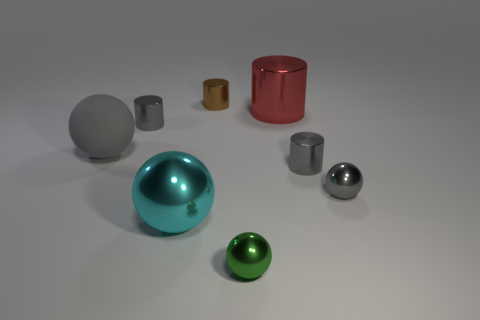What number of tiny objects are behind the big metal sphere and in front of the red metallic cylinder?
Give a very brief answer. 3. Is the number of tiny brown shiny cylinders that are on the right side of the small green shiny object the same as the number of tiny gray shiny cylinders to the right of the red thing?
Ensure brevity in your answer.  No. There is a gray metal cylinder that is to the left of the brown cylinder; is it the same size as the ball in front of the big cyan ball?
Your response must be concise. Yes. There is a small object that is both in front of the big matte ball and on the left side of the big red metallic cylinder; what material is it?
Make the answer very short. Metal. Are there fewer large shiny balls than large blue objects?
Make the answer very short. No. There is a object that is in front of the cyan object on the right side of the large rubber sphere; what is its size?
Your response must be concise. Small. There is a small thing that is in front of the small gray thing in front of the tiny gray metallic cylinder to the right of the brown cylinder; what shape is it?
Give a very brief answer. Sphere. What color is the large cylinder that is the same material as the cyan object?
Your answer should be very brief. Red. What is the color of the ball that is right of the tiny gray cylinder that is to the right of the ball that is in front of the cyan ball?
Make the answer very short. Gray. How many blocks are big brown shiny objects or small brown shiny things?
Give a very brief answer. 0. 